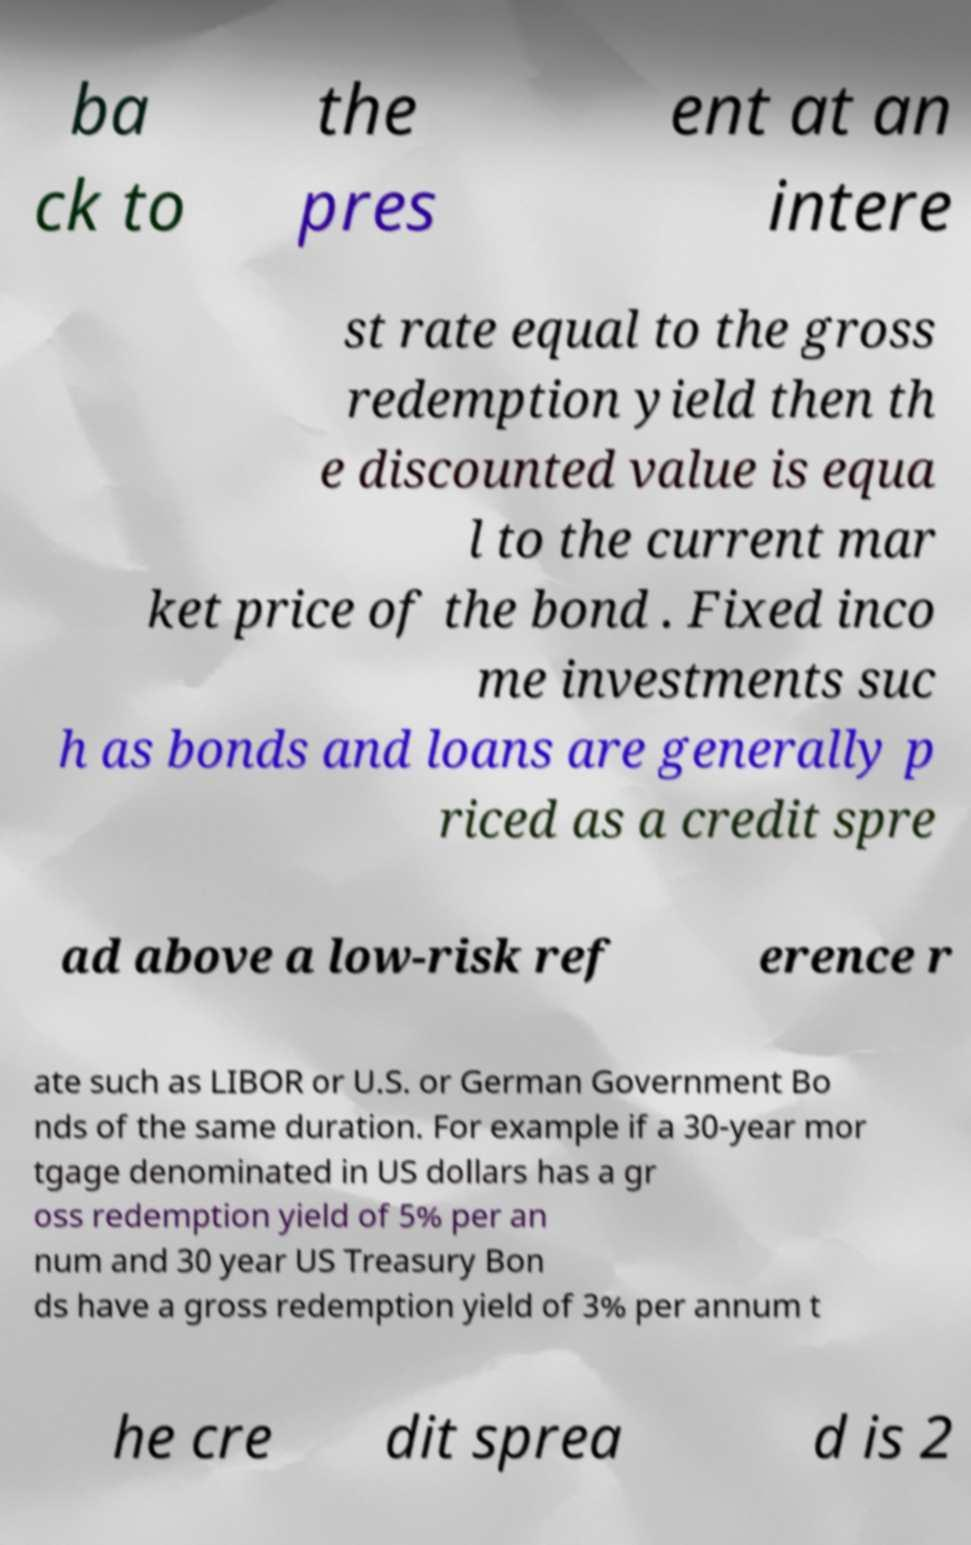Can you accurately transcribe the text from the provided image for me? ba ck to the pres ent at an intere st rate equal to the gross redemption yield then th e discounted value is equa l to the current mar ket price of the bond . Fixed inco me investments suc h as bonds and loans are generally p riced as a credit spre ad above a low-risk ref erence r ate such as LIBOR or U.S. or German Government Bo nds of the same duration. For example if a 30-year mor tgage denominated in US dollars has a gr oss redemption yield of 5% per an num and 30 year US Treasury Bon ds have a gross redemption yield of 3% per annum t he cre dit sprea d is 2 